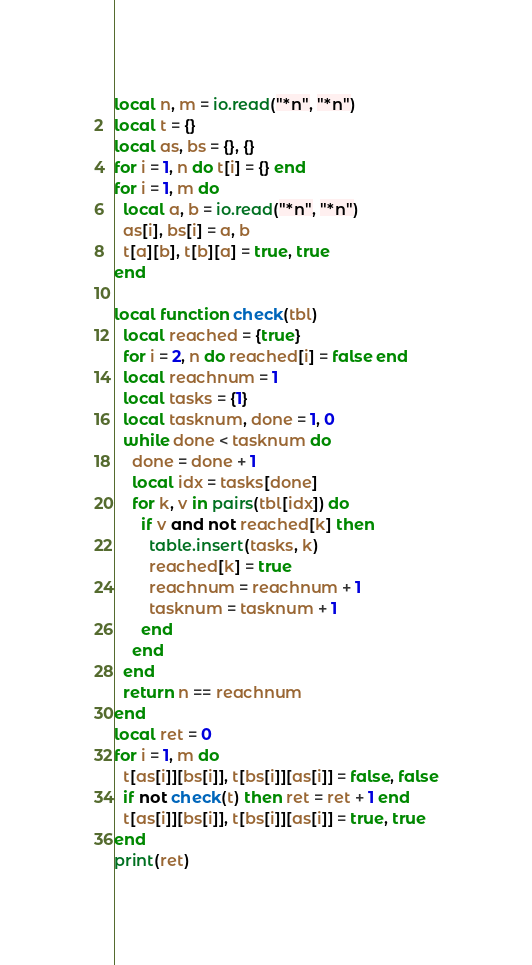<code> <loc_0><loc_0><loc_500><loc_500><_Lua_>local n, m = io.read("*n", "*n")
local t = {}
local as, bs = {}, {}
for i = 1, n do t[i] = {} end
for i = 1, m do
  local a, b = io.read("*n", "*n")
  as[i], bs[i] = a, b
  t[a][b], t[b][a] = true, true
end

local function check(tbl)
  local reached = {true}
  for i = 2, n do reached[i] = false end
  local reachnum = 1
  local tasks = {1}
  local tasknum, done = 1, 0
  while done < tasknum do
    done = done + 1
    local idx = tasks[done]
    for k, v in pairs(tbl[idx]) do
      if v and not reached[k] then
        table.insert(tasks, k)
        reached[k] = true
        reachnum = reachnum + 1
        tasknum = tasknum + 1
      end
    end
  end
  return n == reachnum
end
local ret = 0
for i = 1, m do
  t[as[i]][bs[i]], t[bs[i]][as[i]] = false, false
  if not check(t) then ret = ret + 1 end
  t[as[i]][bs[i]], t[bs[i]][as[i]] = true, true
end
print(ret)
</code> 